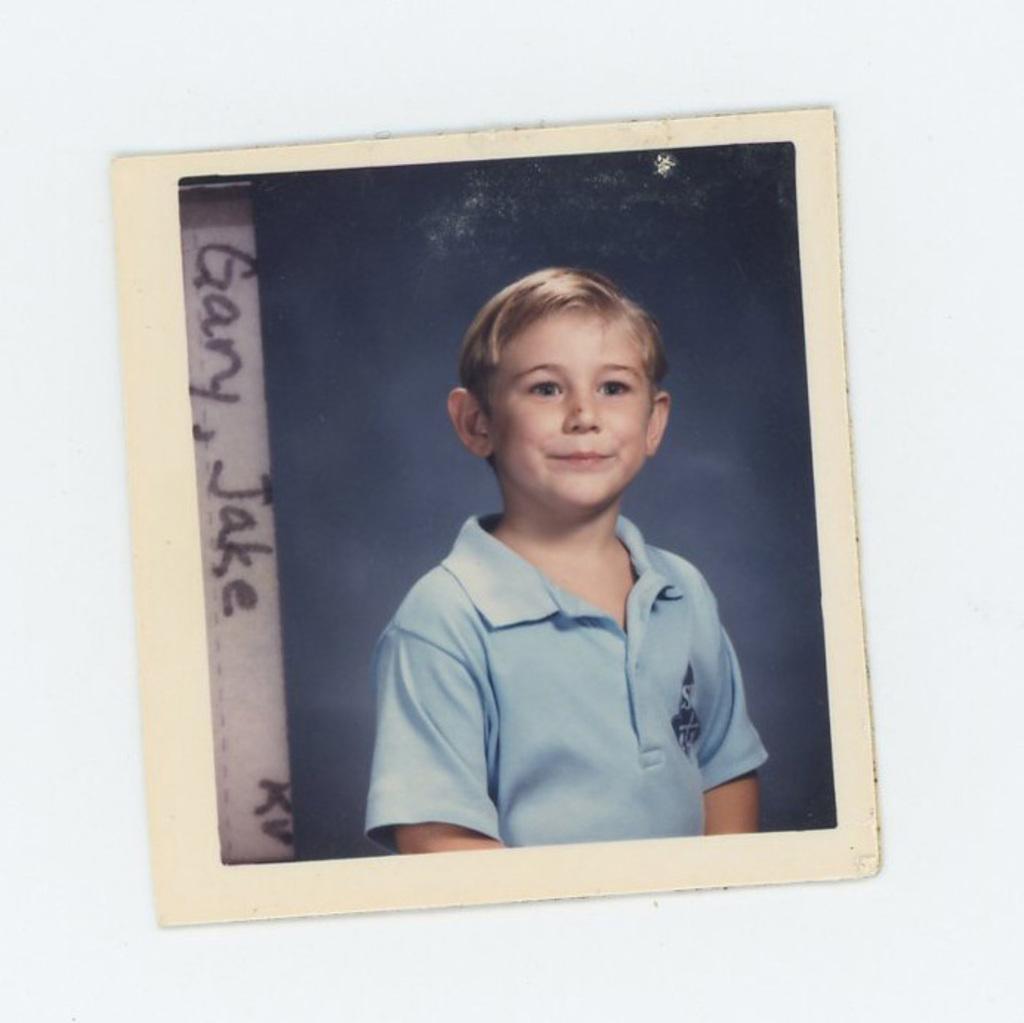Can you describe this image briefly? In this image there is a photo frame on the wall. In the photo frame there is a depiction of a person and there is some text on it. 